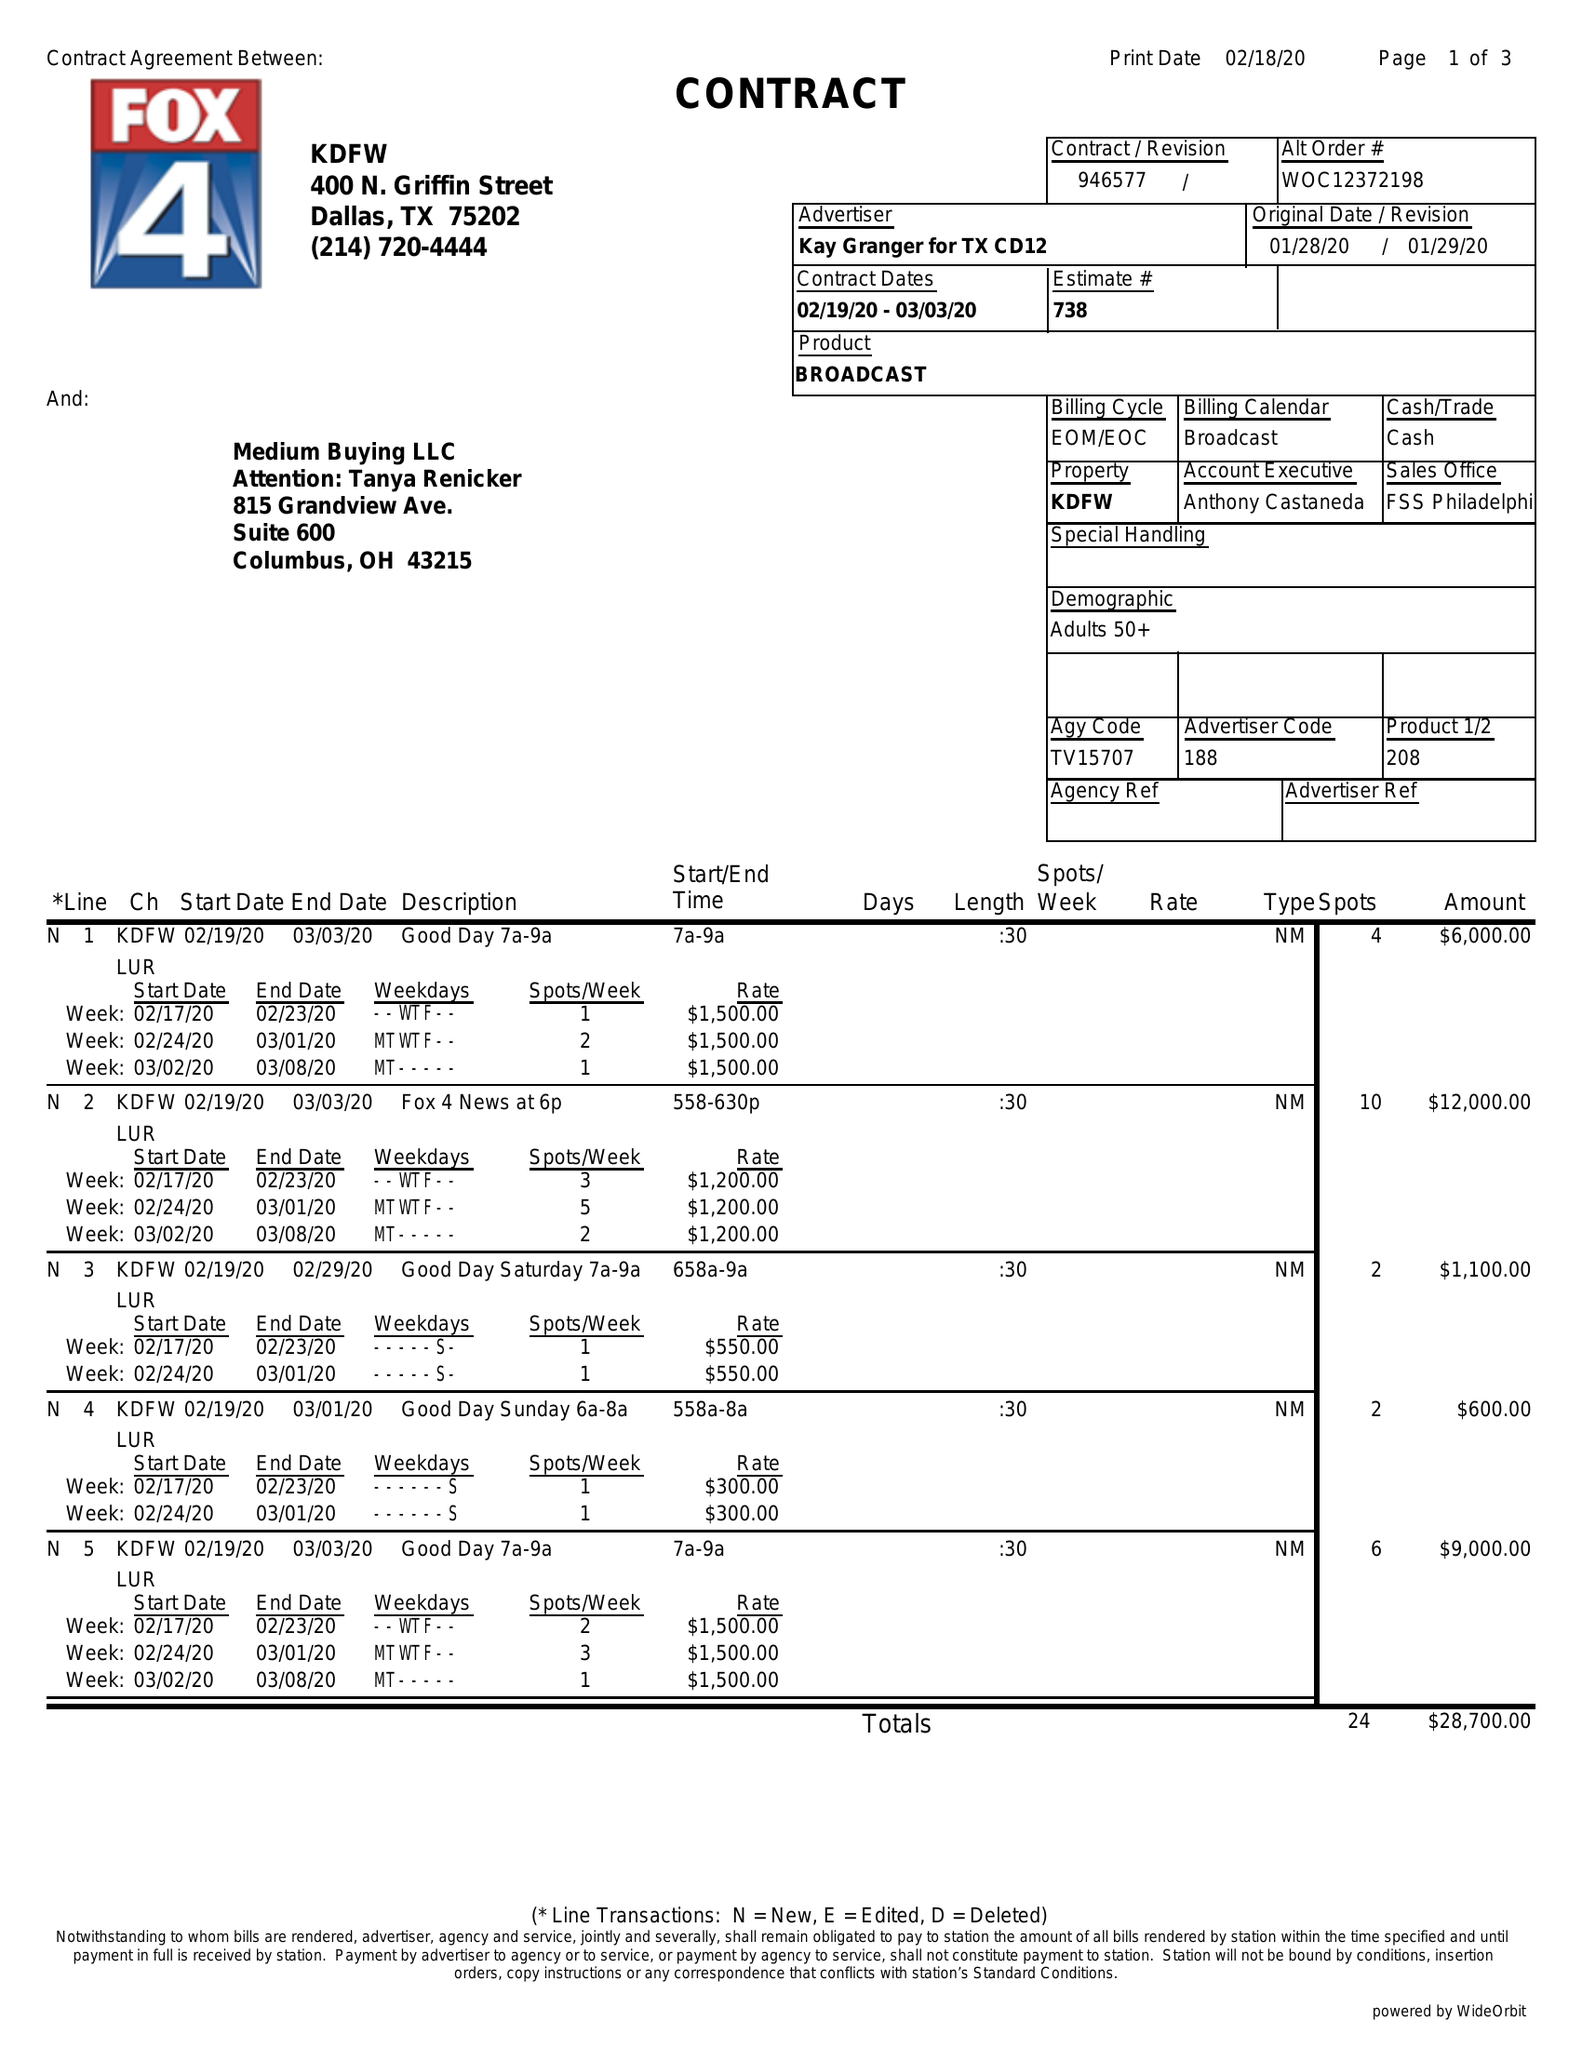What is the value for the flight_to?
Answer the question using a single word or phrase. 03/03/20 